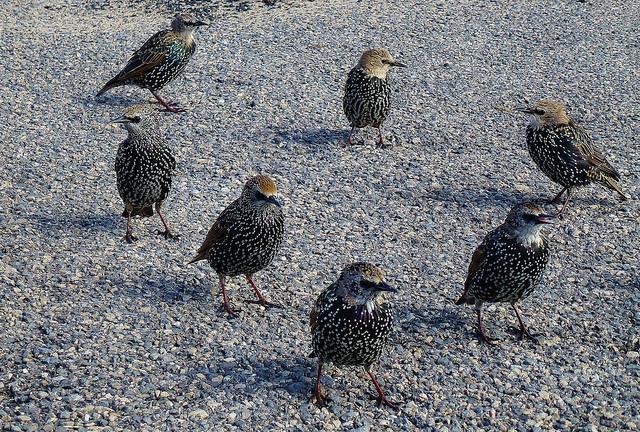How many birds are looking to the left?
Give a very brief answer. 2. How many birds are in the photo?
Give a very brief answer. 7. How many knives are visible?
Give a very brief answer. 0. 